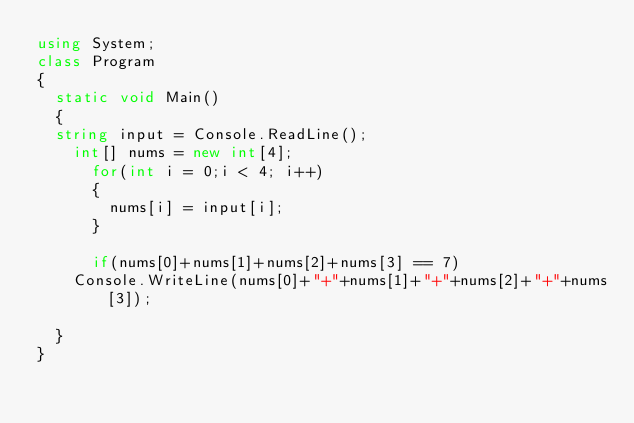<code> <loc_0><loc_0><loc_500><loc_500><_C#_>using System;
class Program
{
	static void Main()
	{
	string input = Console.ReadLine();
    int[] nums = new int[4];
      for(int i = 0;i < 4; i++)
      {
        nums[i] = input[i];
      }
      
      if(nums[0]+nums[1]+nums[2]+nums[3] == 7)
		Console.WriteLine(nums[0]+"+"+nums[1]+"+"+nums[2]+"+"+nums[3]);

	}
}</code> 